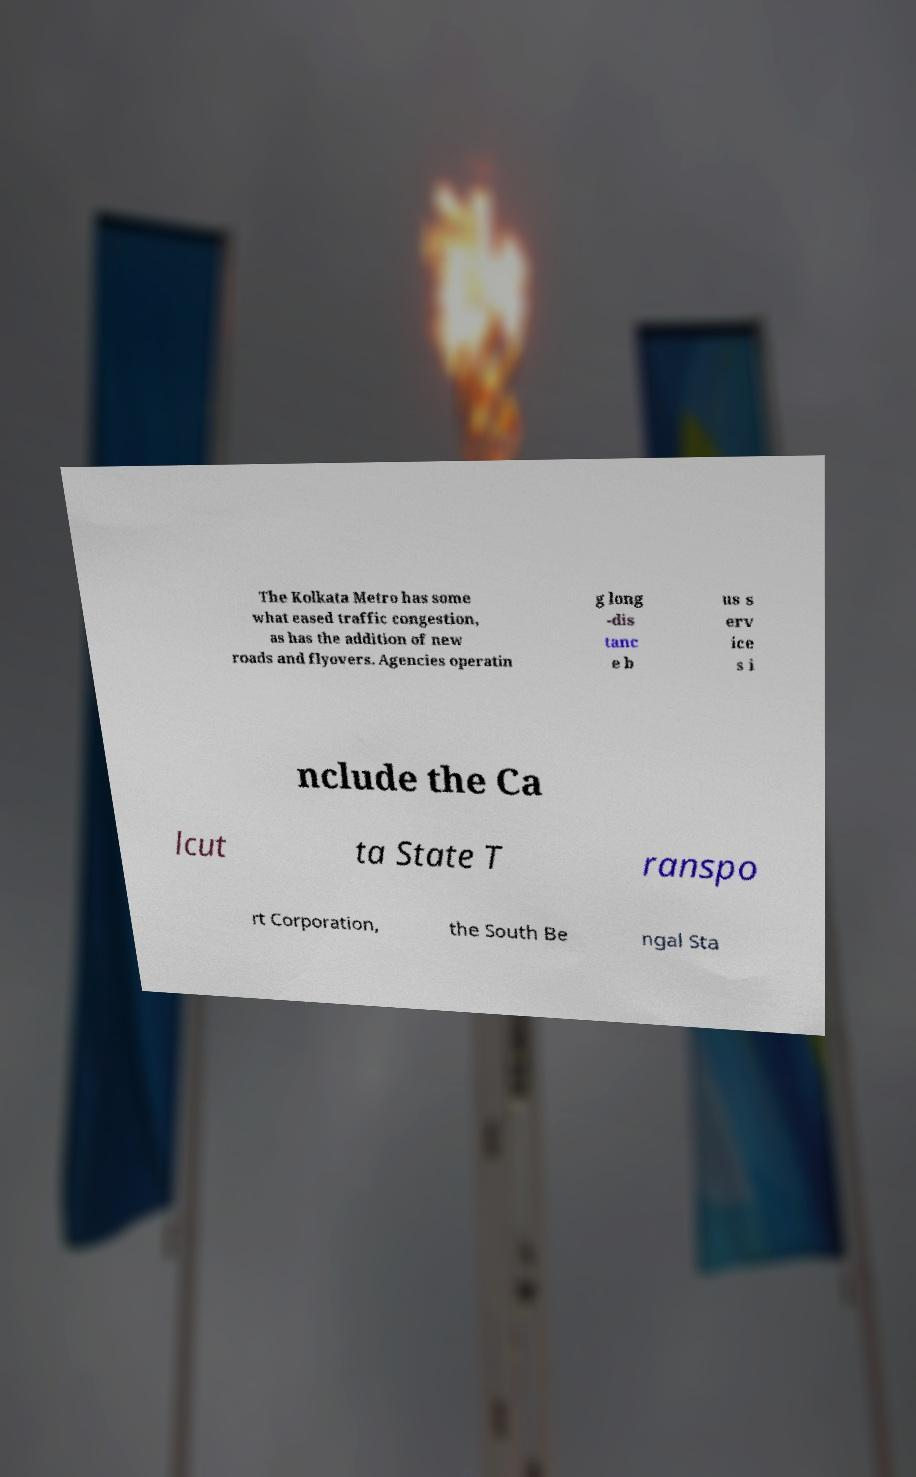For documentation purposes, I need the text within this image transcribed. Could you provide that? The Kolkata Metro has some what eased traffic congestion, as has the addition of new roads and flyovers. Agencies operatin g long -dis tanc e b us s erv ice s i nclude the Ca lcut ta State T ranspo rt Corporation, the South Be ngal Sta 